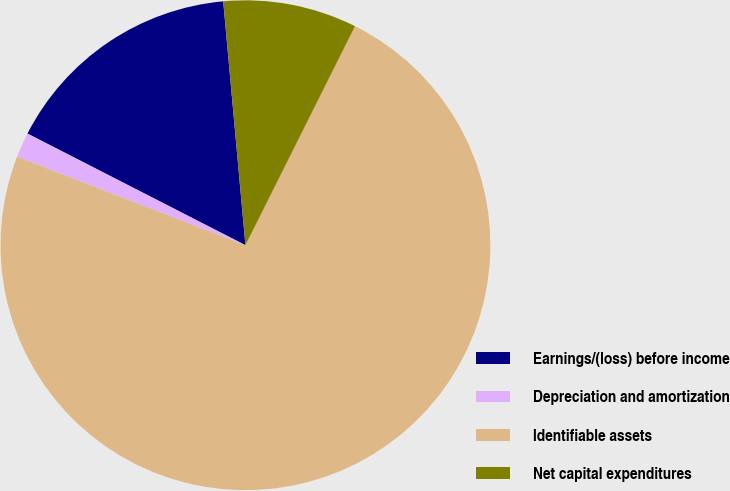<chart> <loc_0><loc_0><loc_500><loc_500><pie_chart><fcel>Earnings/(loss) before income<fcel>Depreciation and amortization<fcel>Identifiable assets<fcel>Net capital expenditures<nl><fcel>16.02%<fcel>1.65%<fcel>73.5%<fcel>8.83%<nl></chart> 